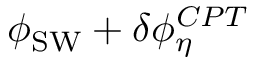<formula> <loc_0><loc_0><loc_500><loc_500>\phi _ { S W } + \delta \phi _ { \eta } ^ { C P T }</formula> 